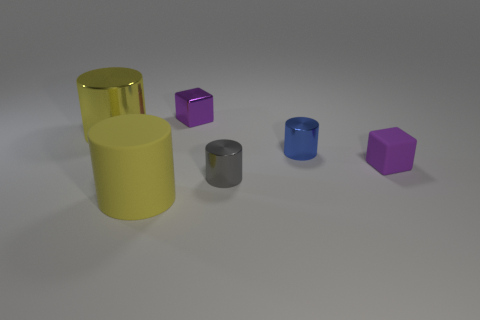The yellow shiny thing has what size?
Provide a short and direct response. Large. The large thing that is the same color as the big matte cylinder is what shape?
Give a very brief answer. Cylinder. What number of spheres are big objects or metallic things?
Keep it short and to the point. 0. Is the number of large metal cylinders that are on the right side of the tiny gray metallic cylinder the same as the number of yellow objects right of the blue metal thing?
Provide a short and direct response. Yes. What is the size of the gray shiny thing that is the same shape as the small blue thing?
Your response must be concise. Small. What size is the metallic cylinder that is to the right of the large rubber cylinder and behind the small gray shiny cylinder?
Your answer should be compact. Small. Are there any cylinders on the right side of the small shiny block?
Give a very brief answer. Yes. How many things are either metallic things that are right of the small purple shiny object or yellow metal objects?
Your answer should be compact. 3. There is a small block behind the small matte block; what number of yellow metallic cylinders are on the right side of it?
Provide a short and direct response. 0. Are there fewer purple metallic things in front of the yellow rubber object than purple blocks in front of the yellow shiny object?
Ensure brevity in your answer.  Yes. 